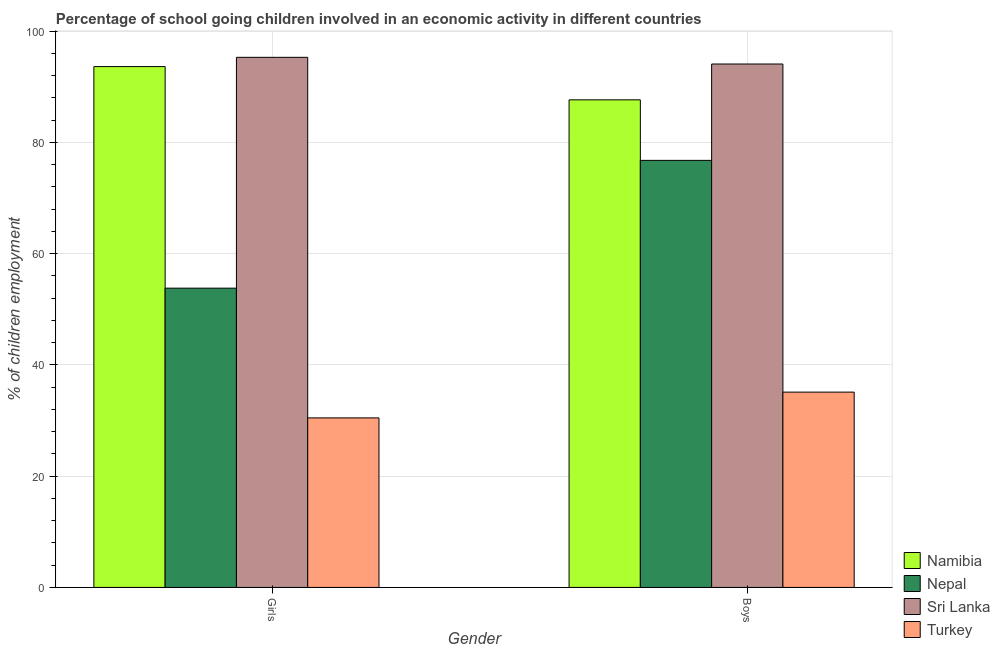How many different coloured bars are there?
Your answer should be compact. 4. What is the label of the 1st group of bars from the left?
Provide a short and direct response. Girls. What is the percentage of school going boys in Turkey?
Offer a terse response. 35.11. Across all countries, what is the maximum percentage of school going boys?
Offer a very short reply. 94.1. Across all countries, what is the minimum percentage of school going girls?
Offer a terse response. 30.48. In which country was the percentage of school going boys maximum?
Offer a terse response. Sri Lanka. What is the total percentage of school going girls in the graph?
Provide a short and direct response. 273.21. What is the difference between the percentage of school going boys in Sri Lanka and that in Nepal?
Offer a terse response. 17.32. What is the difference between the percentage of school going girls in Namibia and the percentage of school going boys in Turkey?
Ensure brevity in your answer.  58.52. What is the average percentage of school going boys per country?
Offer a terse response. 73.41. What is the difference between the percentage of school going boys and percentage of school going girls in Sri Lanka?
Offer a very short reply. -1.2. In how many countries, is the percentage of school going girls greater than 48 %?
Offer a very short reply. 3. What is the ratio of the percentage of school going boys in Namibia to that in Sri Lanka?
Give a very brief answer. 0.93. Is the percentage of school going girls in Turkey less than that in Sri Lanka?
Make the answer very short. Yes. What does the 3rd bar from the left in Girls represents?
Give a very brief answer. Sri Lanka. What does the 2nd bar from the right in Boys represents?
Offer a terse response. Sri Lanka. How many bars are there?
Offer a very short reply. 8. How many countries are there in the graph?
Provide a short and direct response. 4. What is the difference between two consecutive major ticks on the Y-axis?
Give a very brief answer. 20. Are the values on the major ticks of Y-axis written in scientific E-notation?
Your answer should be very brief. No. Does the graph contain any zero values?
Your response must be concise. No. Does the graph contain grids?
Keep it short and to the point. Yes. Where does the legend appear in the graph?
Ensure brevity in your answer.  Bottom right. How many legend labels are there?
Provide a short and direct response. 4. What is the title of the graph?
Make the answer very short. Percentage of school going children involved in an economic activity in different countries. Does "Rwanda" appear as one of the legend labels in the graph?
Provide a short and direct response. No. What is the label or title of the X-axis?
Your response must be concise. Gender. What is the label or title of the Y-axis?
Offer a very short reply. % of children employment. What is the % of children employment of Namibia in Girls?
Keep it short and to the point. 93.64. What is the % of children employment in Nepal in Girls?
Provide a short and direct response. 53.8. What is the % of children employment in Sri Lanka in Girls?
Offer a very short reply. 95.3. What is the % of children employment in Turkey in Girls?
Ensure brevity in your answer.  30.48. What is the % of children employment in Namibia in Boys?
Your answer should be compact. 87.66. What is the % of children employment of Nepal in Boys?
Your answer should be very brief. 76.78. What is the % of children employment of Sri Lanka in Boys?
Your answer should be very brief. 94.1. What is the % of children employment in Turkey in Boys?
Keep it short and to the point. 35.11. Across all Gender, what is the maximum % of children employment of Namibia?
Offer a terse response. 93.64. Across all Gender, what is the maximum % of children employment of Nepal?
Make the answer very short. 76.78. Across all Gender, what is the maximum % of children employment in Sri Lanka?
Ensure brevity in your answer.  95.3. Across all Gender, what is the maximum % of children employment in Turkey?
Make the answer very short. 35.11. Across all Gender, what is the minimum % of children employment of Namibia?
Offer a terse response. 87.66. Across all Gender, what is the minimum % of children employment of Nepal?
Ensure brevity in your answer.  53.8. Across all Gender, what is the minimum % of children employment in Sri Lanka?
Your response must be concise. 94.1. Across all Gender, what is the minimum % of children employment of Turkey?
Provide a succinct answer. 30.48. What is the total % of children employment in Namibia in the graph?
Give a very brief answer. 181.29. What is the total % of children employment in Nepal in the graph?
Keep it short and to the point. 130.58. What is the total % of children employment in Sri Lanka in the graph?
Your answer should be very brief. 189.4. What is the total % of children employment of Turkey in the graph?
Your response must be concise. 65.59. What is the difference between the % of children employment in Namibia in Girls and that in Boys?
Your answer should be very brief. 5.98. What is the difference between the % of children employment of Nepal in Girls and that in Boys?
Make the answer very short. -22.98. What is the difference between the % of children employment in Turkey in Girls and that in Boys?
Ensure brevity in your answer.  -4.64. What is the difference between the % of children employment of Namibia in Girls and the % of children employment of Nepal in Boys?
Your answer should be very brief. 16.86. What is the difference between the % of children employment in Namibia in Girls and the % of children employment in Sri Lanka in Boys?
Ensure brevity in your answer.  -0.46. What is the difference between the % of children employment of Namibia in Girls and the % of children employment of Turkey in Boys?
Your answer should be compact. 58.52. What is the difference between the % of children employment in Nepal in Girls and the % of children employment in Sri Lanka in Boys?
Your response must be concise. -40.3. What is the difference between the % of children employment in Nepal in Girls and the % of children employment in Turkey in Boys?
Ensure brevity in your answer.  18.69. What is the difference between the % of children employment in Sri Lanka in Girls and the % of children employment in Turkey in Boys?
Provide a succinct answer. 60.19. What is the average % of children employment of Namibia per Gender?
Your answer should be very brief. 90.65. What is the average % of children employment in Nepal per Gender?
Offer a terse response. 65.29. What is the average % of children employment in Sri Lanka per Gender?
Make the answer very short. 94.7. What is the average % of children employment in Turkey per Gender?
Give a very brief answer. 32.79. What is the difference between the % of children employment of Namibia and % of children employment of Nepal in Girls?
Offer a very short reply. 39.84. What is the difference between the % of children employment in Namibia and % of children employment in Sri Lanka in Girls?
Offer a terse response. -1.66. What is the difference between the % of children employment in Namibia and % of children employment in Turkey in Girls?
Ensure brevity in your answer.  63.16. What is the difference between the % of children employment in Nepal and % of children employment in Sri Lanka in Girls?
Ensure brevity in your answer.  -41.5. What is the difference between the % of children employment in Nepal and % of children employment in Turkey in Girls?
Your response must be concise. 23.32. What is the difference between the % of children employment of Sri Lanka and % of children employment of Turkey in Girls?
Your answer should be very brief. 64.82. What is the difference between the % of children employment in Namibia and % of children employment in Nepal in Boys?
Provide a succinct answer. 10.88. What is the difference between the % of children employment in Namibia and % of children employment in Sri Lanka in Boys?
Provide a succinct answer. -6.44. What is the difference between the % of children employment of Namibia and % of children employment of Turkey in Boys?
Your answer should be compact. 52.54. What is the difference between the % of children employment in Nepal and % of children employment in Sri Lanka in Boys?
Offer a very short reply. -17.32. What is the difference between the % of children employment of Nepal and % of children employment of Turkey in Boys?
Your answer should be very brief. 41.66. What is the difference between the % of children employment in Sri Lanka and % of children employment in Turkey in Boys?
Your response must be concise. 58.99. What is the ratio of the % of children employment in Namibia in Girls to that in Boys?
Provide a short and direct response. 1.07. What is the ratio of the % of children employment in Nepal in Girls to that in Boys?
Make the answer very short. 0.7. What is the ratio of the % of children employment of Sri Lanka in Girls to that in Boys?
Make the answer very short. 1.01. What is the ratio of the % of children employment of Turkey in Girls to that in Boys?
Give a very brief answer. 0.87. What is the difference between the highest and the second highest % of children employment of Namibia?
Your response must be concise. 5.98. What is the difference between the highest and the second highest % of children employment of Nepal?
Make the answer very short. 22.98. What is the difference between the highest and the second highest % of children employment of Sri Lanka?
Provide a succinct answer. 1.2. What is the difference between the highest and the second highest % of children employment in Turkey?
Offer a terse response. 4.64. What is the difference between the highest and the lowest % of children employment in Namibia?
Make the answer very short. 5.98. What is the difference between the highest and the lowest % of children employment in Nepal?
Your response must be concise. 22.98. What is the difference between the highest and the lowest % of children employment in Sri Lanka?
Give a very brief answer. 1.2. What is the difference between the highest and the lowest % of children employment of Turkey?
Provide a succinct answer. 4.64. 